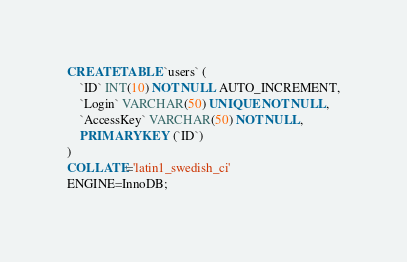Convert code to text. <code><loc_0><loc_0><loc_500><loc_500><_SQL_>CREATE TABLE `users` (
	`ID` INT(10) NOT NULL AUTO_INCREMENT,
	`Login` VARCHAR(50) UNIQUE NOT NULL,
	`AccessKey` VARCHAR(50) NOT NULL,
	PRIMARY KEY (`ID`)
)
COLLATE='latin1_swedish_ci'
ENGINE=InnoDB;</code> 